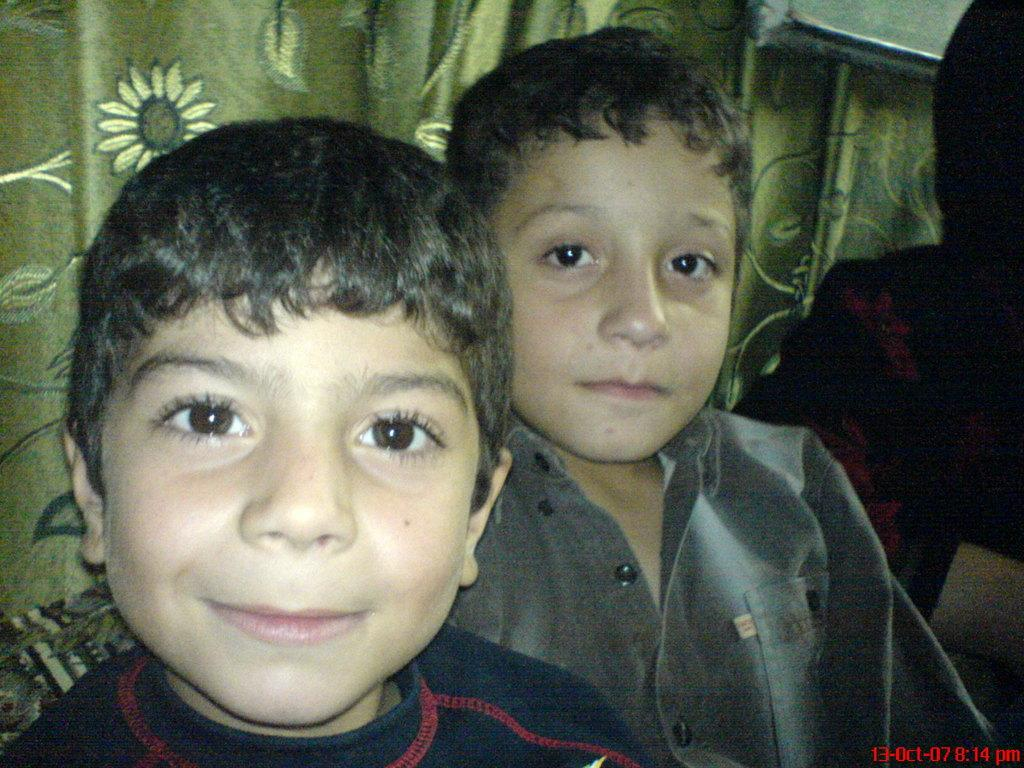How many boys are in the image? There are two boys in the image. Can you describe the expression on the face of one of the boys? The boy on the left side appears to be smiling. What can be seen in the background of the image? There are curtains visible in the background of the image. What direction is the man facing in the image? There is no man present in the image; it only features two boys. 